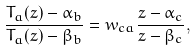Convert formula to latex. <formula><loc_0><loc_0><loc_500><loc_500>\frac { T _ { a } ( z ) - \alpha _ { b } } { T _ { a } ( z ) - \beta _ { b } } = w _ { c a } \frac { z - \alpha _ { c } } { z - \beta _ { c } } ,</formula> 